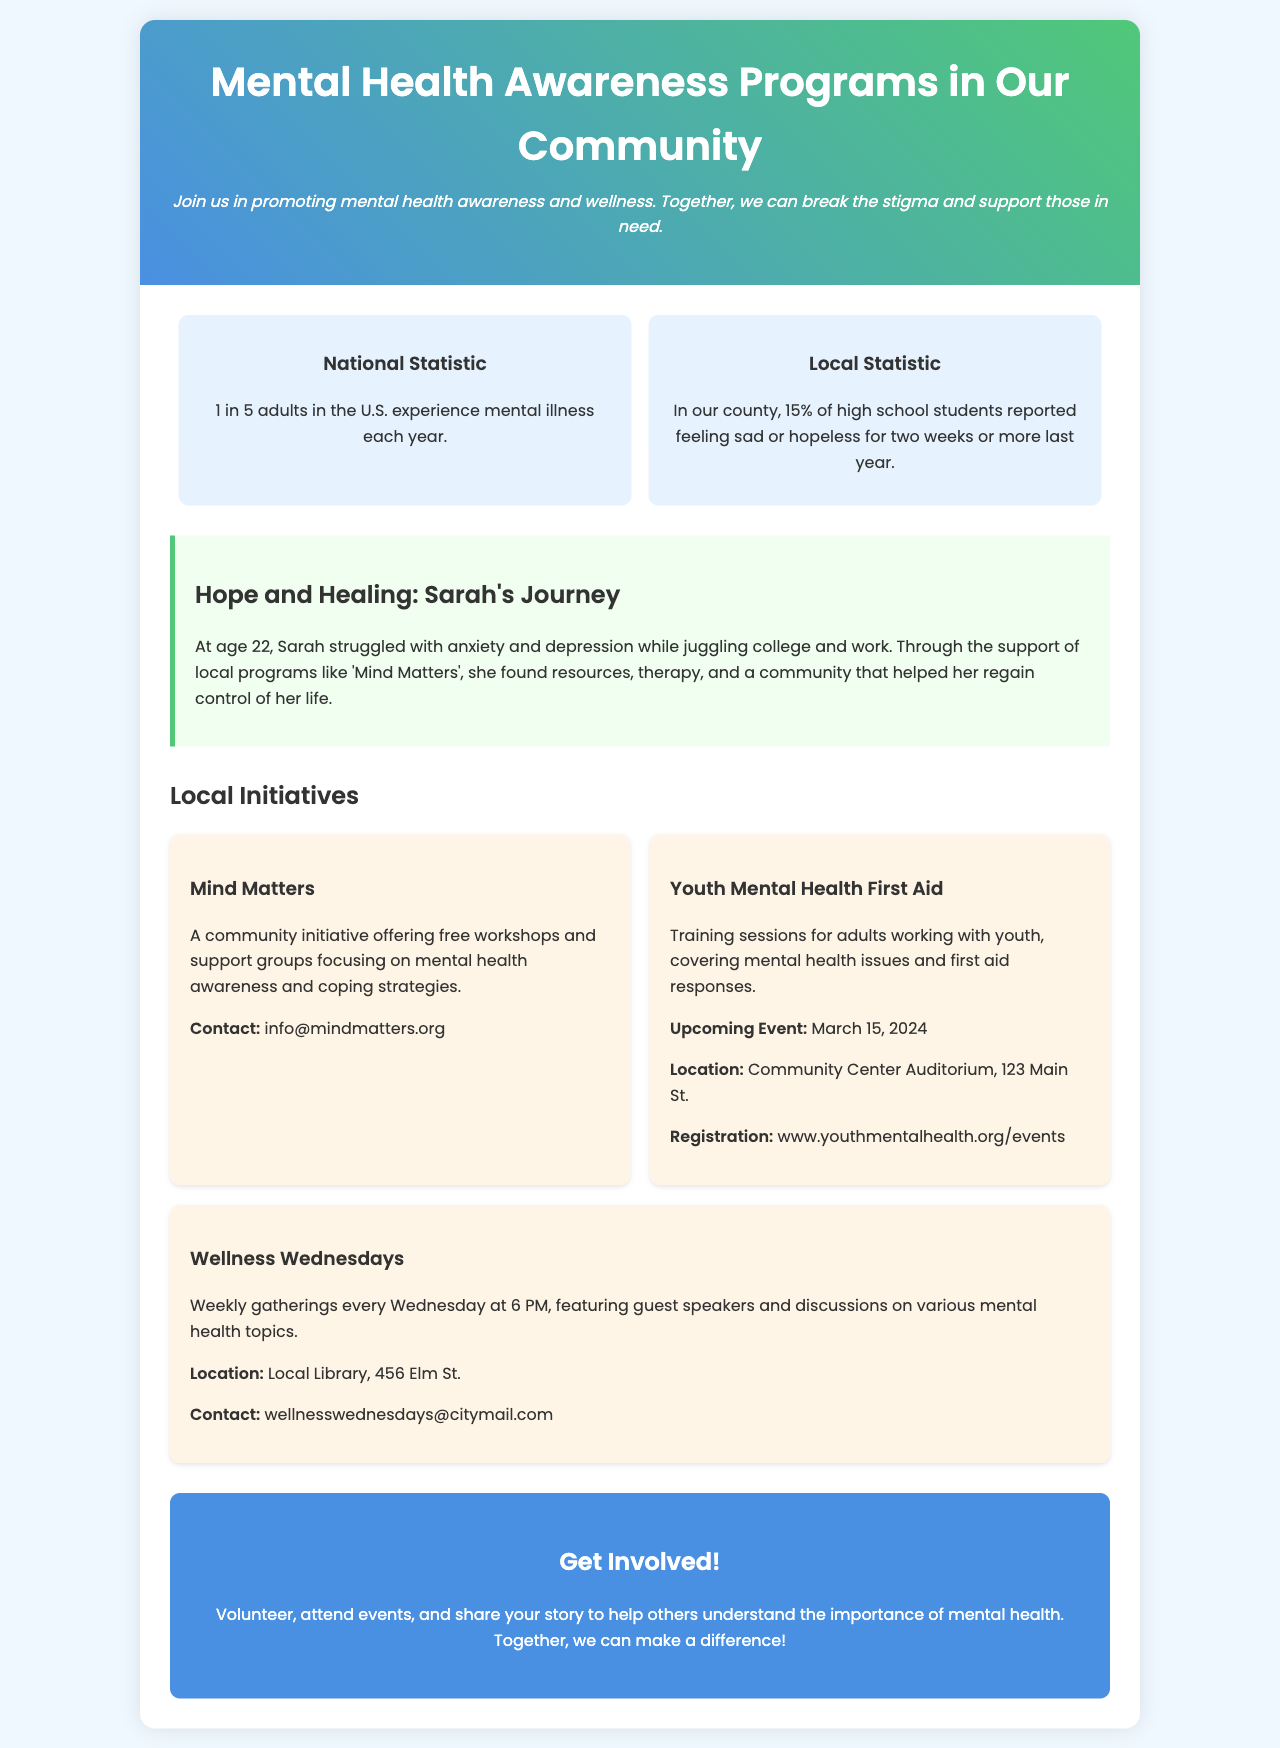What percentage of high school students reported feeling sad or hopeless? The document states that 15% of high school students in the county reported feeling sad or hopeless for two weeks or more last year.
Answer: 15% What is Sarah's age in her journey story? Sarah is mentioned to be 22 years old in her personal story.
Answer: 22 What is the name of the community initiative offering free workshops? The brochure mentions 'Mind Matters' as the community initiative offering free workshops and support groups.
Answer: Mind Matters When is the Youth Mental Health First Aid training session? The document specifies that the upcoming event for Youth Mental Health First Aid is on March 15, 2024.
Answer: March 15, 2024 Where is the Wellness Wednesdays gathering held? The document states that Wellness Wednesdays is held at the Local Library, 456 Elm St.
Answer: Local Library, 456 Elm St What is the main goal of Mental Health Awareness Programs mentioned in the brochure? The introduction in the brochure discusses promoting mental health awareness and wellness and breaking the stigma.
Answer: Promoting mental health awareness and wellness What type of events can you get involved in according to the brochure? The call to action suggests volunteering, attending events, and sharing your story to help others.
Answer: Volunteering and attending events What contact information is provided for the Mind Matters initiative? The brochure lists the contact for Mind Matters as info@mindmatters.org.
Answer: info@mindmatters.org 